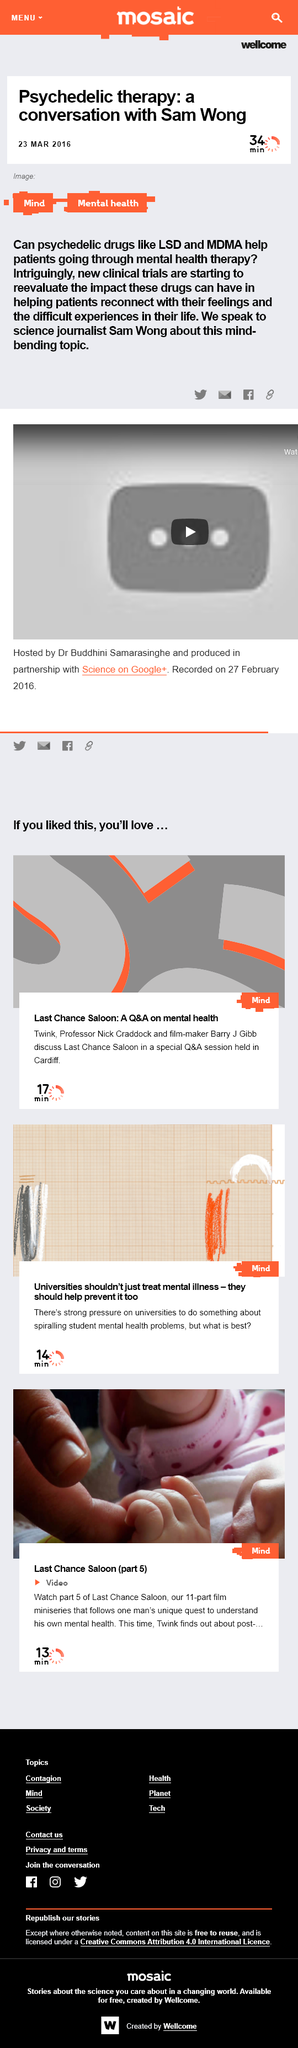List a handful of essential elements in this visual. The article on a conversation with Sam Wong was published on March 23, 2016. Sam Wong and his colleagues discussed the topic of psychedelic therapy during their conversation. Sam Wong is a science journalist who possesses the profession of reporting and writing about scientific developments, discoveries, and theories. 